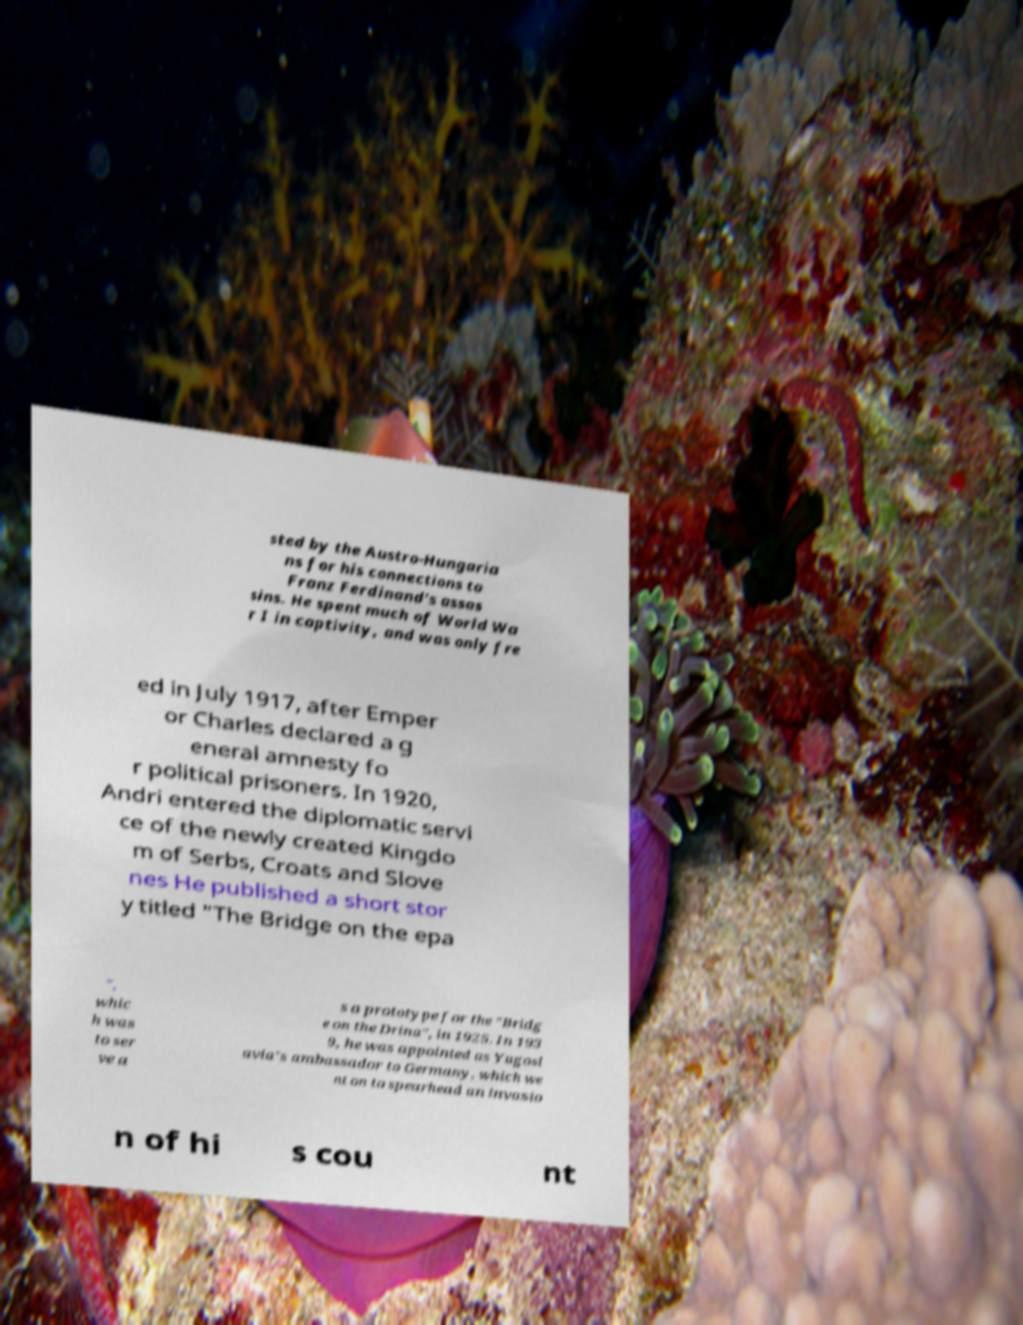For documentation purposes, I need the text within this image transcribed. Could you provide that? sted by the Austro-Hungaria ns for his connections to Franz Ferdinand's assas sins. He spent much of World Wa r I in captivity, and was only fre ed in July 1917, after Emper or Charles declared a g eneral amnesty fo r political prisoners. In 1920, Andri entered the diplomatic servi ce of the newly created Kingdo m of Serbs, Croats and Slove nes He published a short stor y titled "The Bridge on the epa ", whic h was to ser ve a s a prototype for the "Bridg e on the Drina", in 1925. In 193 9, he was appointed as Yugosl avia's ambassador to Germany, which we nt on to spearhead an invasio n of hi s cou nt 